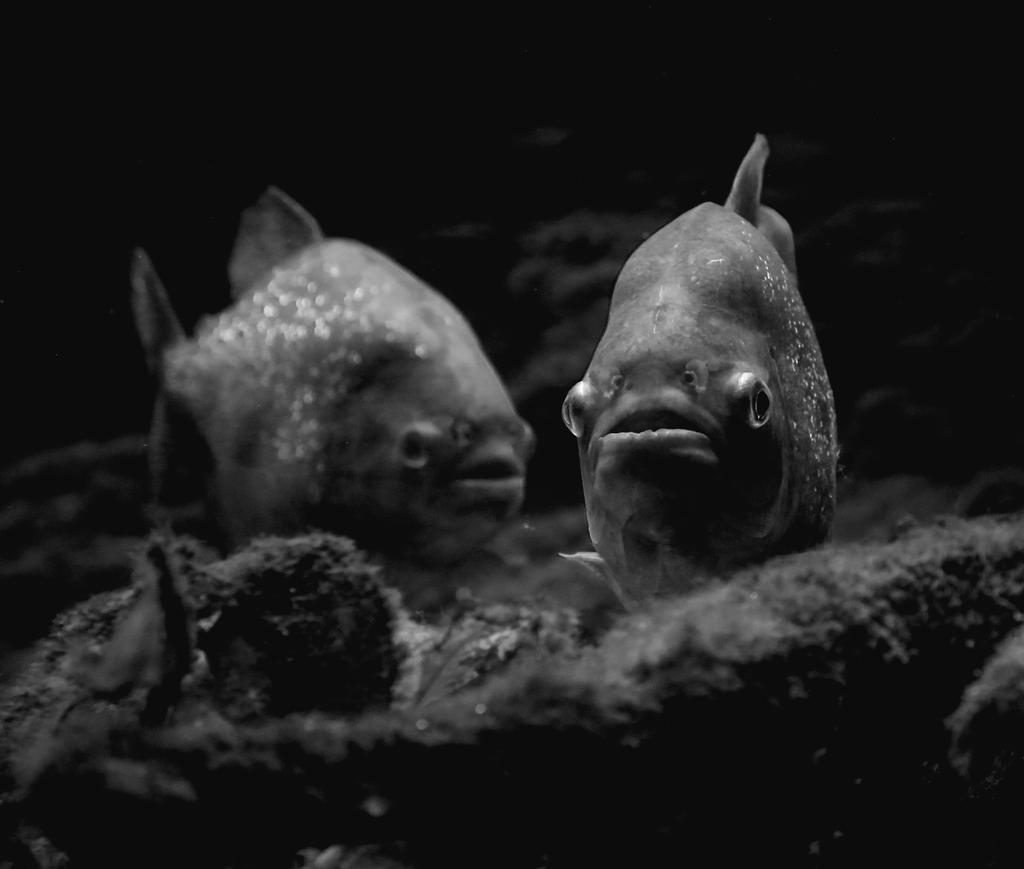Can you describe this image briefly? In this image, we can see two fishes. In the background, we can see black color, at the bottom there is a land. 